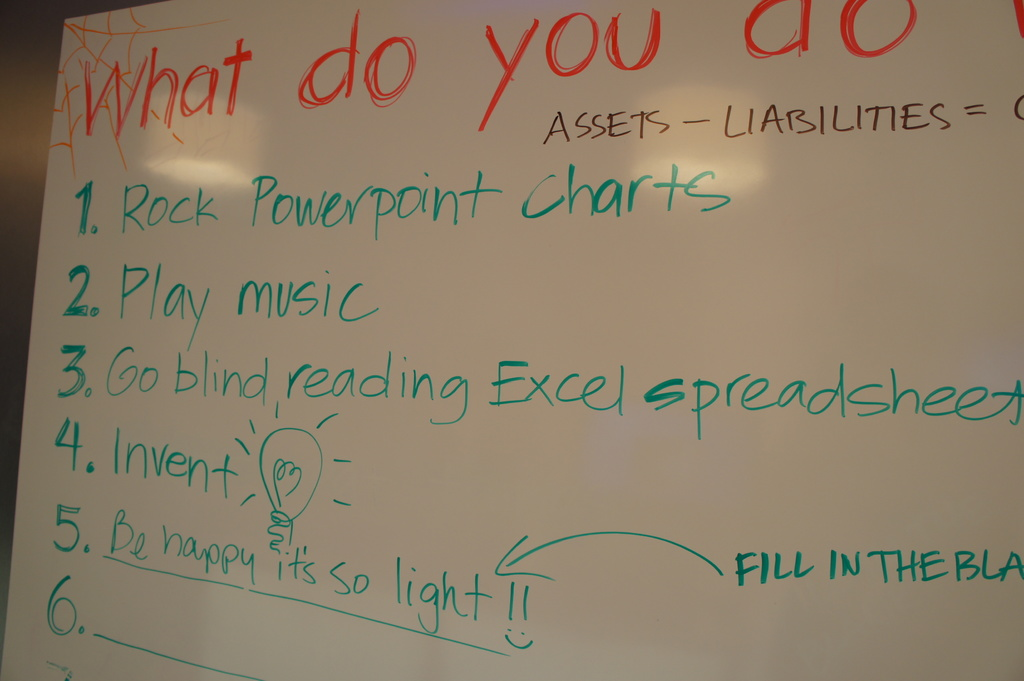What can you infer about the environment or setting from the types and styles of activities listed on this whiteboard? The settings seem to be a creative, possibly educational or office environment where brainstorming and light-hearted activities are encouraged. This is indicated by the mixture of work-related (like PowerPoint charts) and fun (like playing music) tasks. Can you suggest what might be added to the list at point number 6 to fit with the themes of the other activities? Considering the playful and creative spirit reflected in the existing items, adding 'Doodle your best masterpiece' might be a suitable and fun option for point 6. 